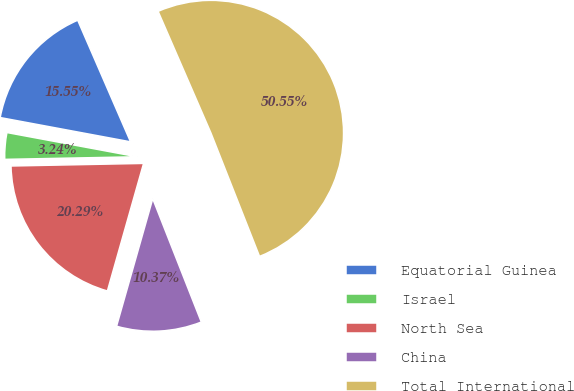<chart> <loc_0><loc_0><loc_500><loc_500><pie_chart><fcel>Equatorial Guinea<fcel>Israel<fcel>North Sea<fcel>China<fcel>Total International<nl><fcel>15.55%<fcel>3.24%<fcel>20.29%<fcel>10.37%<fcel>50.55%<nl></chart> 